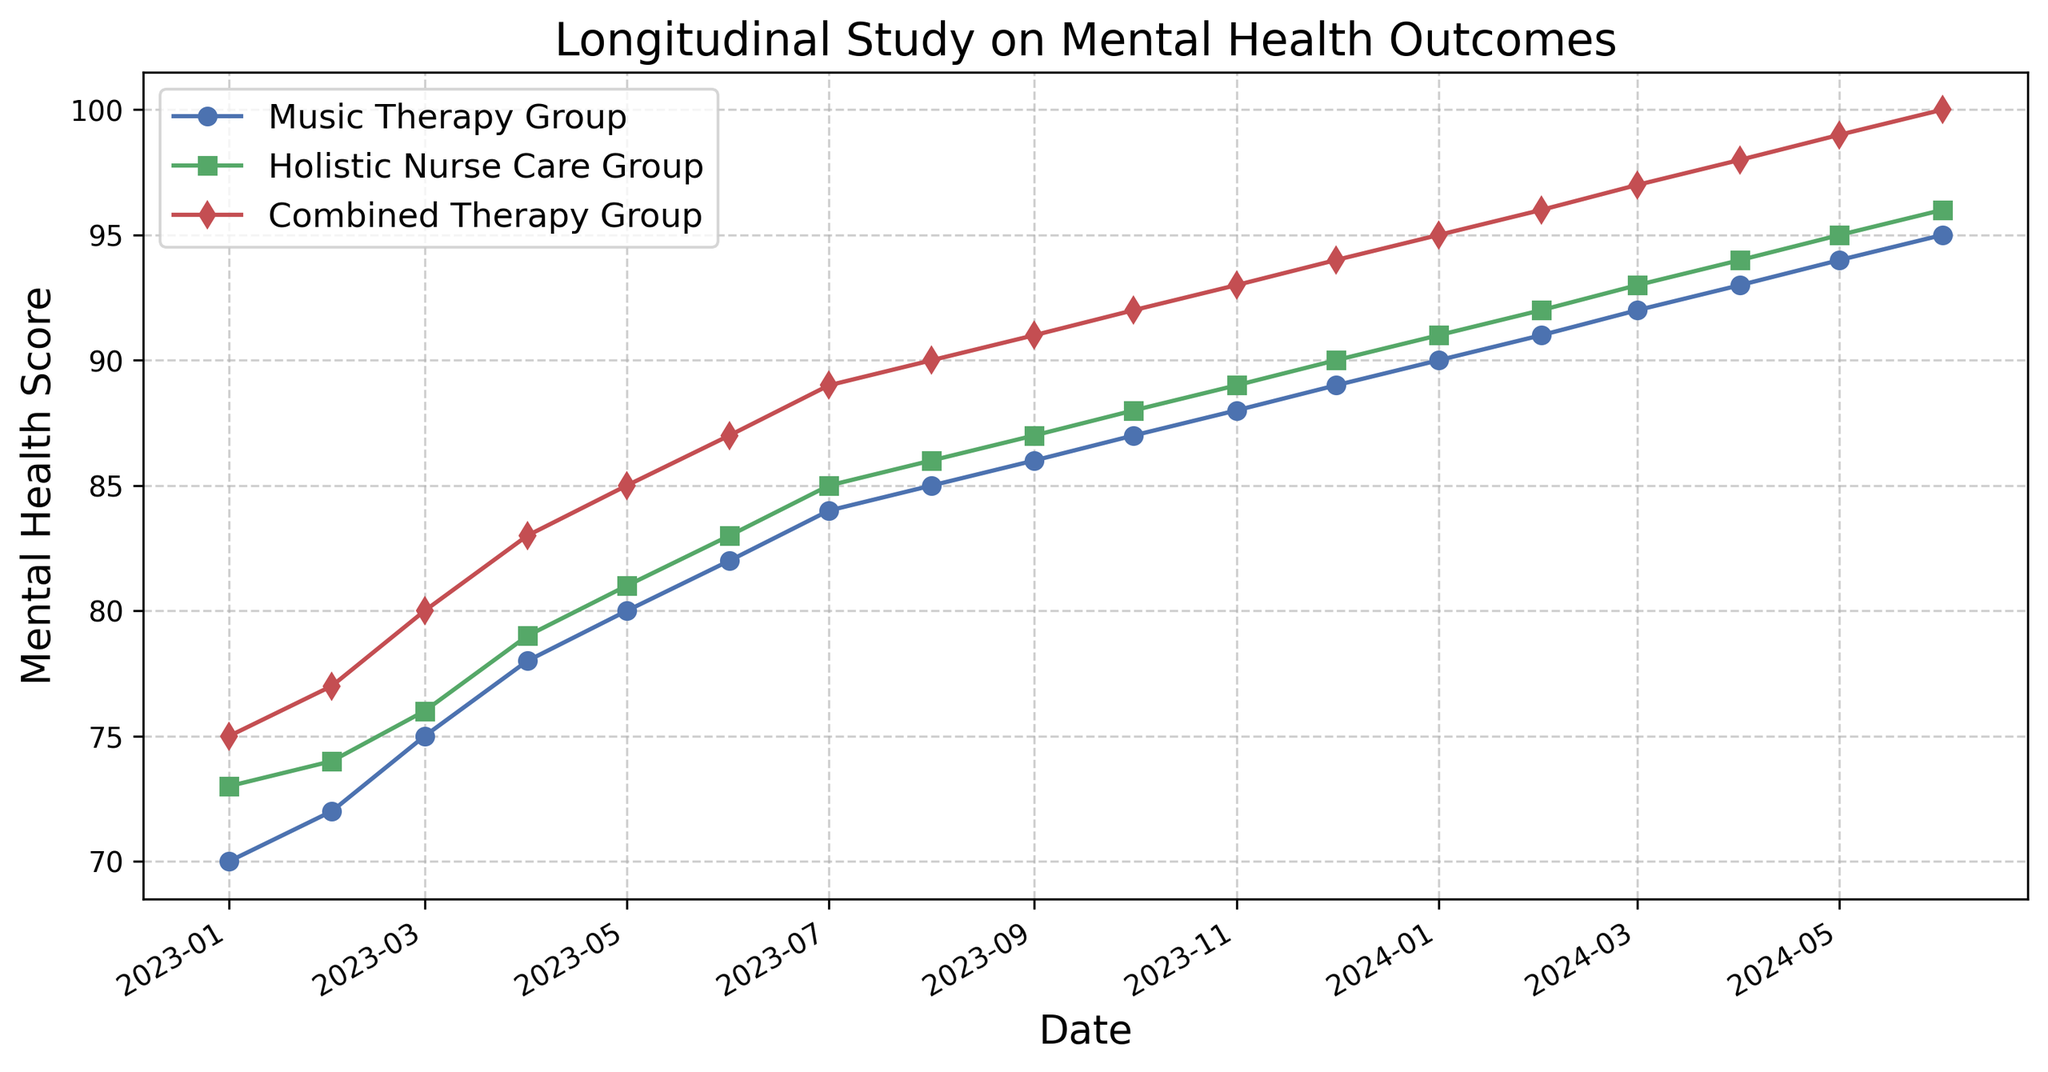What is the mental health score of the Combined Therapy Group in June 2024? To find the mental health score of the Combined Therapy Group in June 2024, locate the point of the Combined Therapy Group series on the x-axis corresponding to June 2024 and read the value on the y-axis.
Answer: 100 What is the difference in the mental health scores of the Music Therapy Group and the Holistic Nurse Care Group in January 2023? Locate the points of both the Music Therapy Group and Holistic Nurse Care Group for January 2023 and subtract the score of the Music Therapy Group from the Holistic Nurse Care Group.
Answer: 3 How many months did it take for the Combined Therapy Group to reach a score of 90? Identify the point where the Combined Therapy Group series first reaches a score of 90, which is in August 2023. Count the months from January 2023 to August 2023.
Answer: 8 months By how much did the mental health score increase for the Holistic Nurse Care Group from April 2023 to April 2024? Find the Holistic Nurse Care Group scores for April 2023 and April 2024 and subtract the two values.
Answer: 15 Which group showed the most improvement between January 2023 and June 2024? Calculate the difference in scores from January 2023 to June 2024 for all three groups. The group with the largest difference shows the most improvement.
Answer: Combined Therapy Group How do the scores of the Music Therapy Group and Holistic Nurse Care Group compare in February 2024? Find the points for both groups in February 2024 and compare their values to see which is higher.
Answer: Holistic Nurse Care Group is higher What is the average score of the Music Therapy Group over the whole period? Sum all the scores of the Music Therapy Group from January 2023 to June 2024 and divide by the number of months (18).
Answer: 84.1 Is there any month where the Music Therapy Group outperformed the Holistic Nurse Care Group? Examine each month's data points for both groups and compare; if the Music Therapy Group's score is higher in any month, note that month.
Answer: No What is the visual trend for all groups across the study period? Observe the line plot for each group from January 2023 to June 2024 and describe the overall direction of the lines.
Answer: Increasing Did the Combined Therapy Group ever have the same score as the Music Therapy Group in any month? Compare the scores of both groups month by month to see if there are any matching values throughout the study period.
Answer: No 